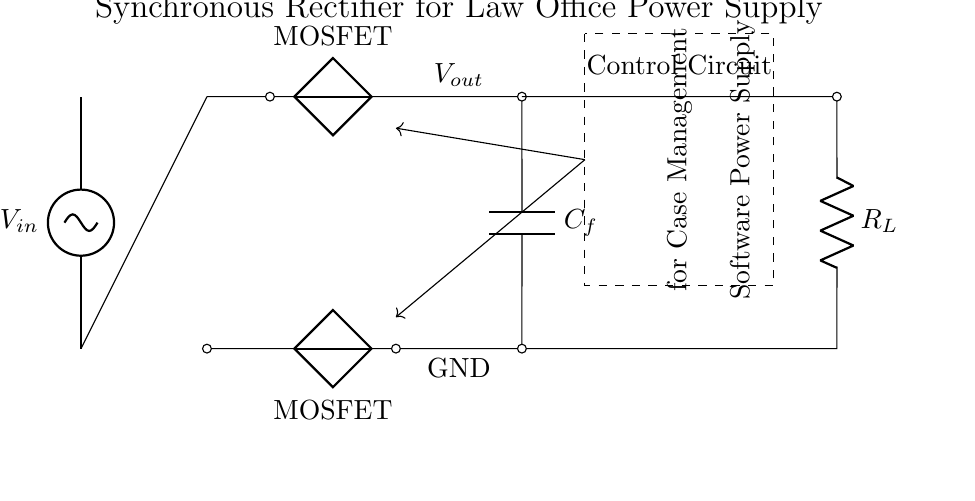What is the type of circuit shown? The circuit is a synchronous rectifier circuit, which typically converts AC input to a DC output using MOSFETs. This is indicated by the presence of the AC source, transformer, and MOSFET components in the diagram.
Answer: synchronous rectifier What is the role of the transformer in this circuit? The transformer steps up or steps down the AC voltage, making it suitable for rectification. In this circuit, it serves to modify the voltage before it reaches the rectifier stage.
Answer: voltage modification What does C_f represent in the circuit? C_f is a filter capacitor, which smooths out the voltage ripple after rectification, thereby providing a steadier DC output. This is a common function of capacitors in power supply circuits.
Answer: filter capacitor How many MOSFETs are present in the circuit? There are two MOSFETs in this synchronous rectifier setup, used to efficiently switch the current direction during the rectification process.
Answer: two What is the purpose of the control circuit? The control circuit regulates the operation of the MOSFETs, ensuring they are turned on and off at the correct times for efficient power conversion, specifically tailored for the case management software.
Answer: regulation of MOSFETs What is the output labeled in the circuit? The output is labeled as V_out, which indicates the voltage provided to the load after rectification and filtering. This is crucial for supplying stable power to devices in the law office.
Answer: V_out What load type is suggested by R_L in the circuit? R_L represents the load resistance, indicating that the circuit is designed to power a resistive load typical for law office computer systems, such as those running case management software.
Answer: resistive load 